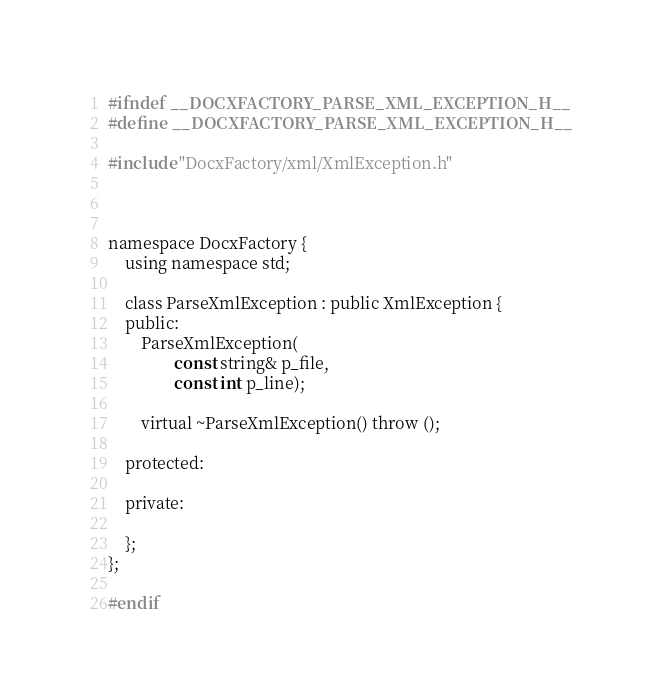<code> <loc_0><loc_0><loc_500><loc_500><_C_>
#ifndef __DOCXFACTORY_PARSE_XML_EXCEPTION_H__
#define __DOCXFACTORY_PARSE_XML_EXCEPTION_H__

#include "DocxFactory/xml/XmlException.h"



namespace DocxFactory {
    using namespace std;

    class ParseXmlException : public XmlException {
    public:
        ParseXmlException(
                const string& p_file,
                const int p_line);

        virtual ~ParseXmlException() throw ();

    protected:

    private:

    };
};

#endif
</code> 